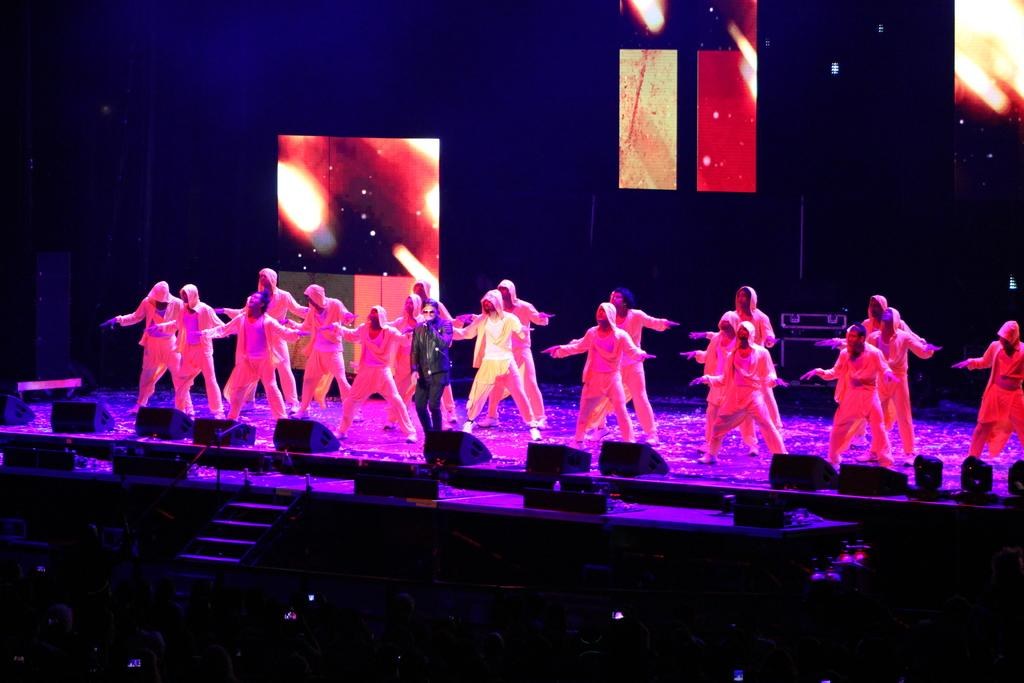What is happening on the stage in the image? There are people on the stage in the image. What can be seen in the background of the stage? There are loudspeakers and lights in the background of the image. How many birds are flying over the hill in the image? There is no hill or birds present in the image. What emotion can be seen on the faces of the people on the stage? The provided facts do not mention the emotions or expressions of the people on the stage, so it cannot be determined from the image. 